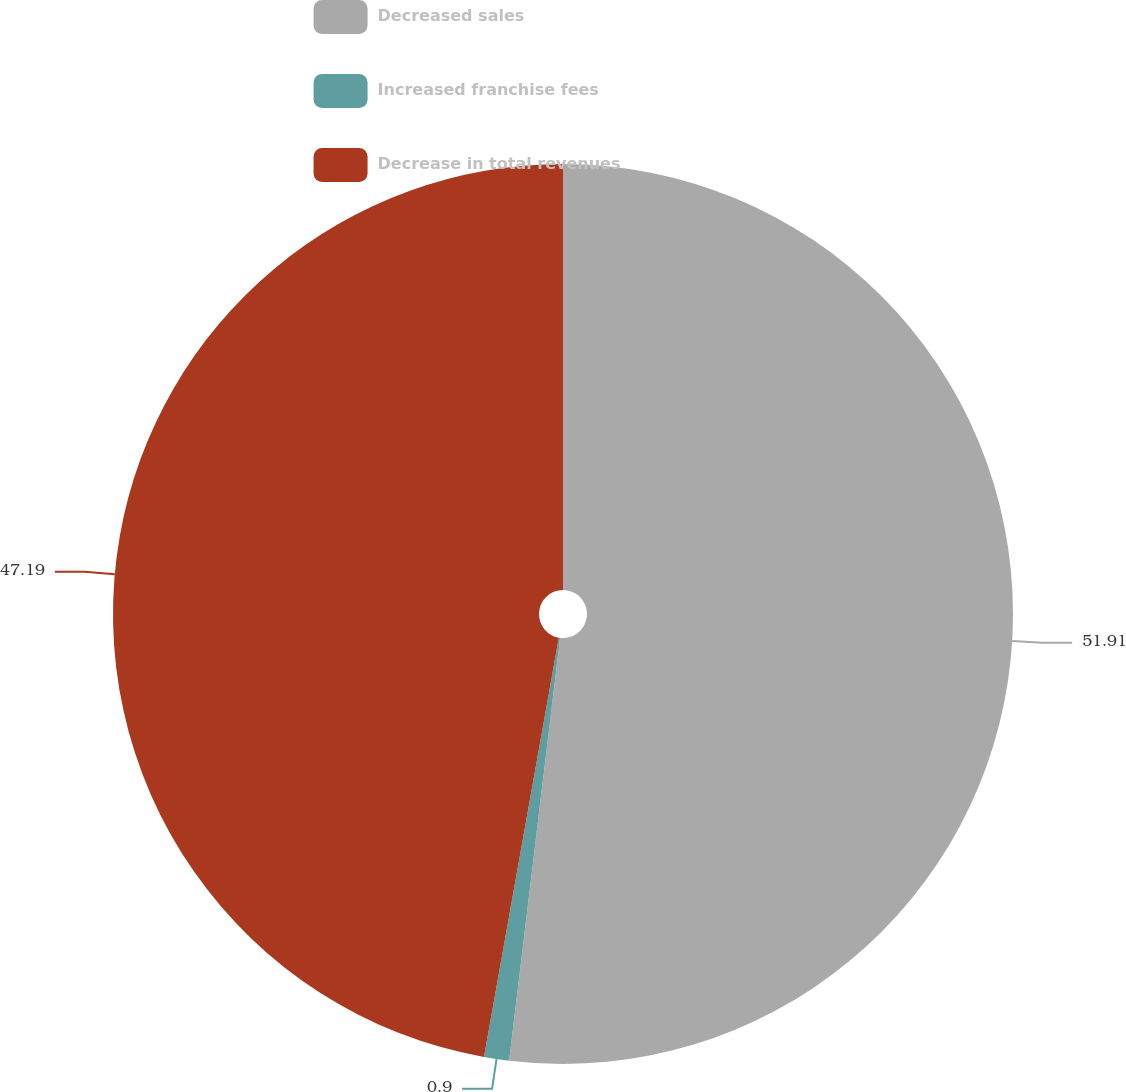Convert chart. <chart><loc_0><loc_0><loc_500><loc_500><pie_chart><fcel>Decreased sales<fcel>Increased franchise fees<fcel>Decrease in total revenues<nl><fcel>51.91%<fcel>0.9%<fcel>47.19%<nl></chart> 